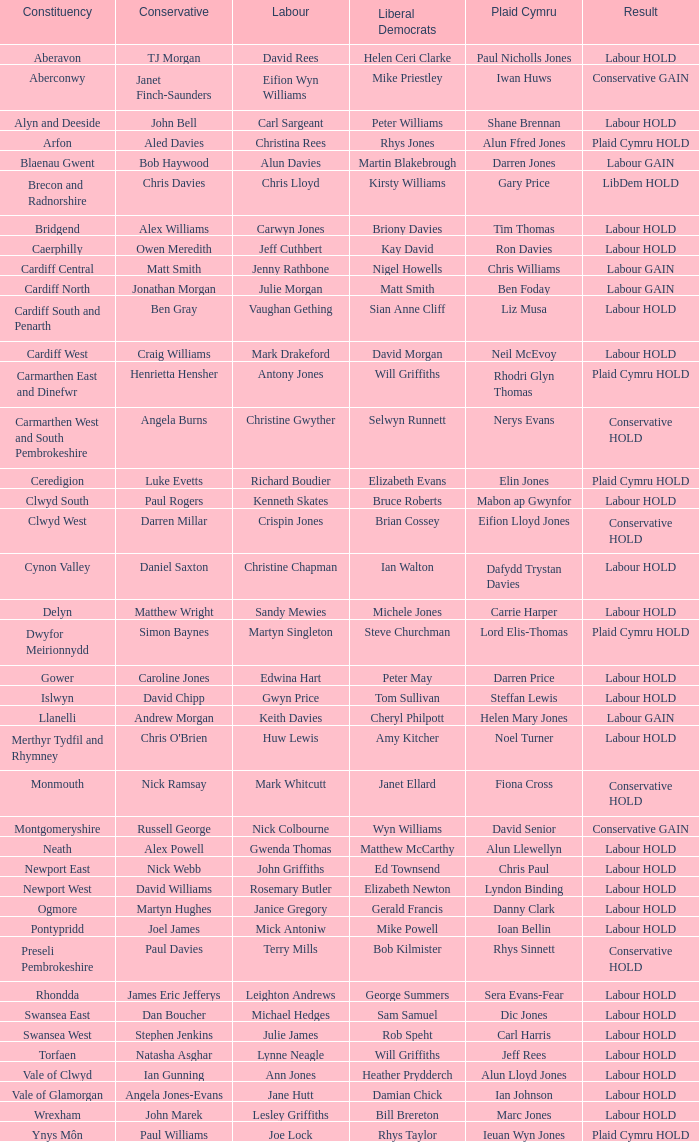In what constituency was the result labour hold and Liberal democrat Elizabeth Newton won? Newport West. 